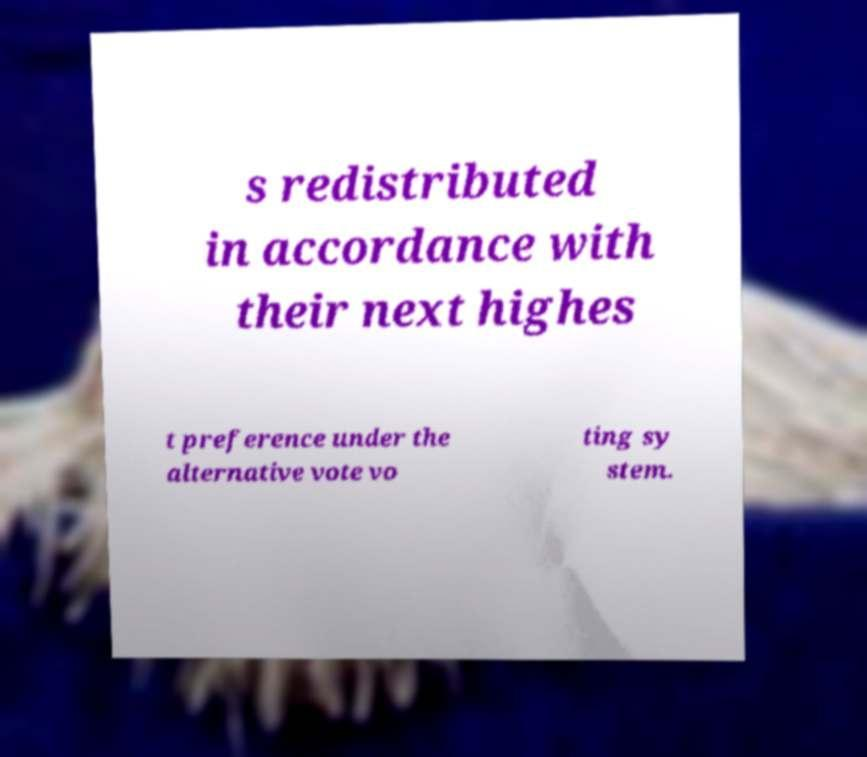Could you assist in decoding the text presented in this image and type it out clearly? s redistributed in accordance with their next highes t preference under the alternative vote vo ting sy stem. 